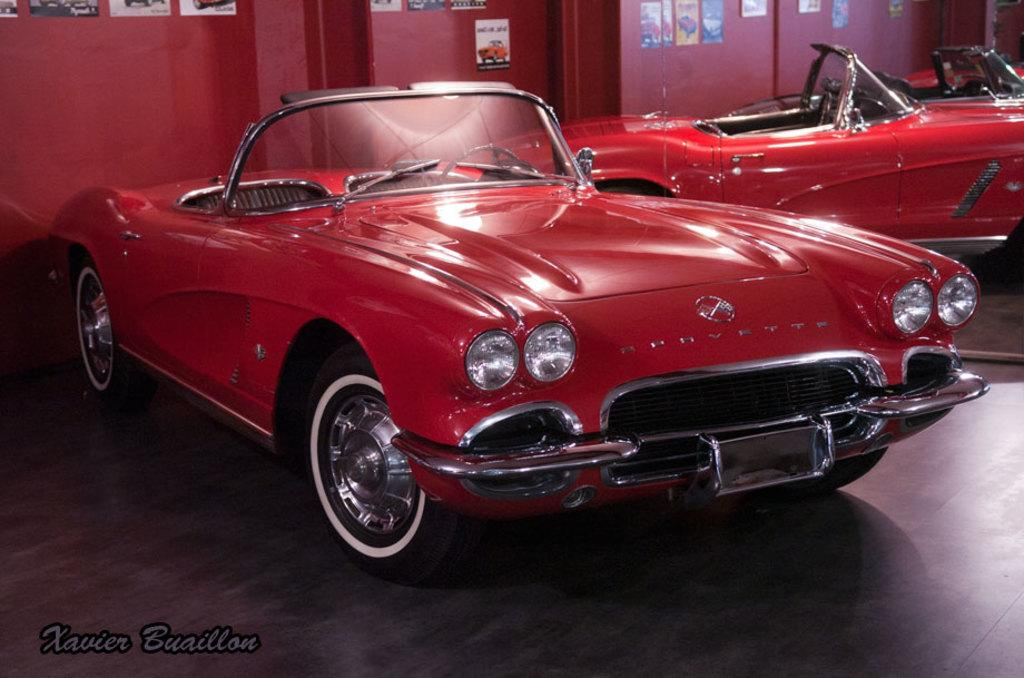What is the main subject in the center of the image? There is a car in the center of the image. Where is the car located? The car is on the floor. What can be seen in the background of the image? There is a mirror, a wall, and posters in the background of the image. Is there any text present in the image? Yes, there is text at the bottom of the image. What type of fork can be seen in the image? There is no fork present in the image. How many pages are visible in the image? There are no pages visible in the image. 